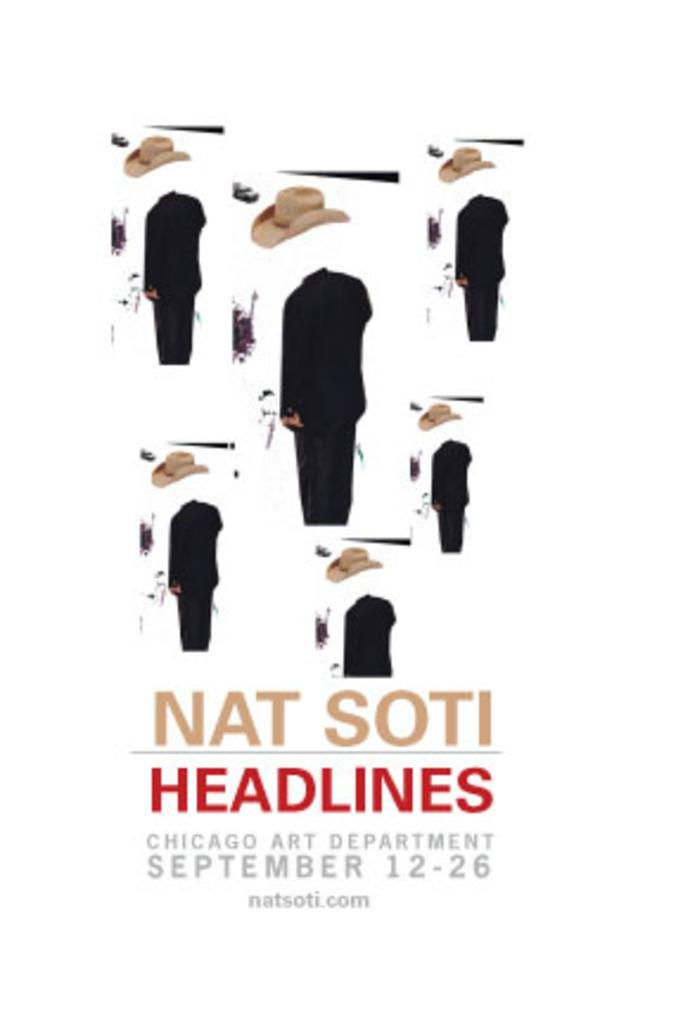What type of objects can be seen in the image? There are caps in the image. Are there any people present in the image? Yes, there are persons in the image. What else can be found in the image besides caps and persons? There is text in the image. What color is the background of the image? The background of the image is white. What type of poison is being used in the competition depicted in the image? There is no competition or poison present in the image; it features caps, persons, and text on a white background. 